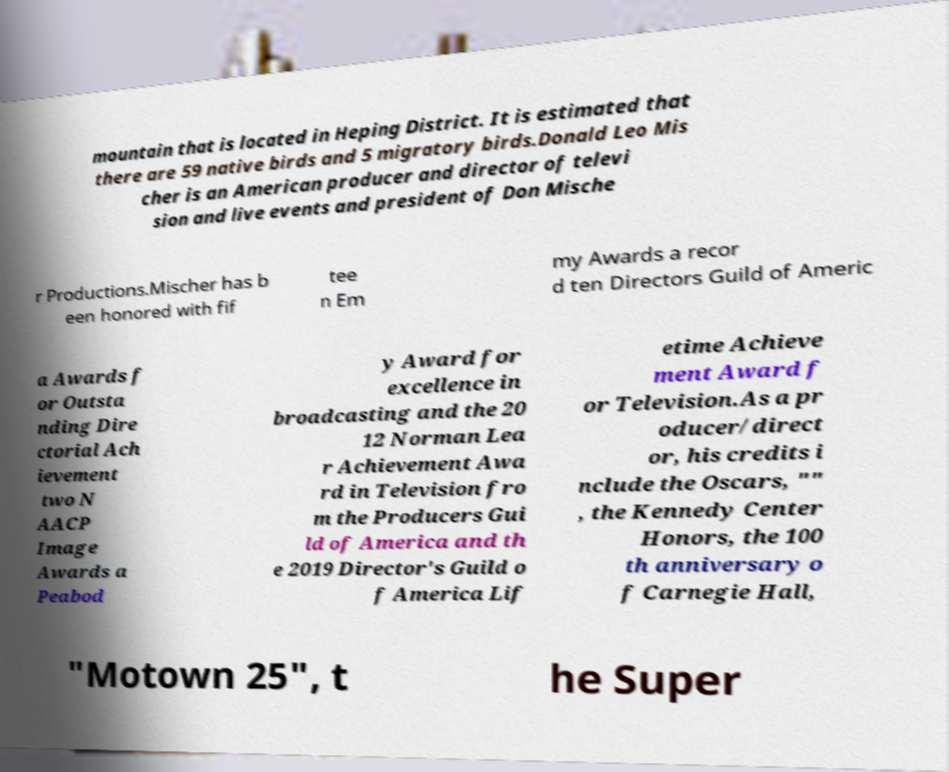I need the written content from this picture converted into text. Can you do that? mountain that is located in Heping District. It is estimated that there are 59 native birds and 5 migratory birds.Donald Leo Mis cher is an American producer and director of televi sion and live events and president of Don Mische r Productions.Mischer has b een honored with fif tee n Em my Awards a recor d ten Directors Guild of Americ a Awards f or Outsta nding Dire ctorial Ach ievement two N AACP Image Awards a Peabod y Award for excellence in broadcasting and the 20 12 Norman Lea r Achievement Awa rd in Television fro m the Producers Gui ld of America and th e 2019 Director's Guild o f America Lif etime Achieve ment Award f or Television.As a pr oducer/direct or, his credits i nclude the Oscars, "" , the Kennedy Center Honors, the 100 th anniversary o f Carnegie Hall, "Motown 25", t he Super 